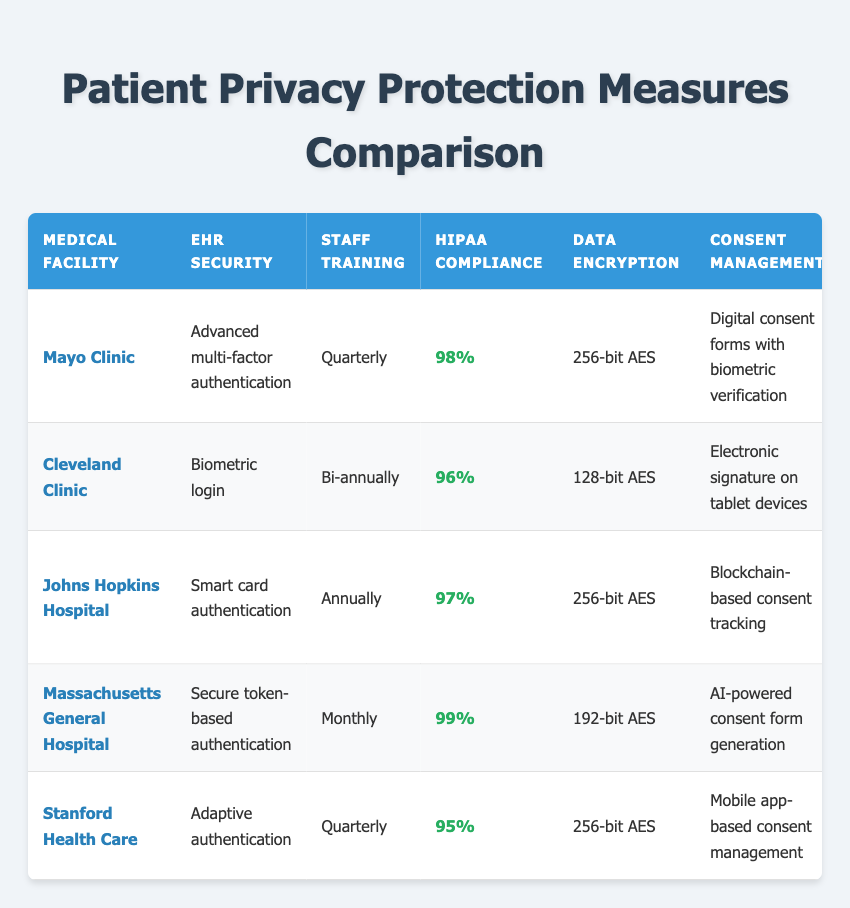What is the highest HIPAA compliance audit score among the facilities? The HIPAA compliance audit scores for the facilities are 98%, 96%, 97%, 99%, and 95%. The highest score is 99%, which belongs to Massachusetts General Hospital.
Answer: 99% How often does Cleveland Clinic conduct staff training? The staff training frequency for Cleveland Clinic is specified in the table as bi-annually.
Answer: Bi-annually Does Johns Hopkins Hospital utilize any form of biometric patient consent management? The table indicates that Johns Hopkins Hospital uses blockchain-based consent tracking for patient consent management, which is a form of digital technology but does not directly mention biometric methods. Therefore, the answer is no.
Answer: No Which facility has the fastest breach notification protocol? The table lists the breach notification protocols: within 24 hours (Mayo Clinic), 48 hours (Cleveland Clinic), 36 hours (Johns Hopkins Hospital), 12 hours (Massachusetts General Hospital), and 72 hours (Stanford Health Care). The fastest is within 12 hours by Massachusetts General Hospital.
Answer: Within 12 hours What is the average HIPAA compliance audit score for all listed facilities? The audit scores are 98%, 96%, 97%, 99%, and 95%. To find the average, sum these scores (98 + 96 + 97 + 99 + 95 = 485) and divide by the number of facilities (485 / 5 = 97). Therefore, the average HIPAA compliance audit score is 97%.
Answer: 97% Which medical facility utilizes two-factor authentication as an access control measure? The table shows that Cleveland Clinic utilizes two-factor authentication for access control measures.
Answer: Cleveland Clinic Is the data encryption level at Mayo Clinic higher than that at Massachusetts General Hospital? The table indicates that Mayo Clinic uses 256-bit AES for data encryption, while Massachusetts General Hospital uses 192-bit AES. Since 256-bit is higher than 192-bit, the answer is yes.
Answer: Yes Which facility has the most frequent staff training sessions? According to the table, Massachusetts General Hospital conducts staff training monthly, which is more frequent than Mayo Clinic (quarterly), Cleveland Clinic (bi-annually), Johns Hopkins Hospital (annually), and Stanford Health Care (quarterly).
Answer: Massachusetts General Hospital What type of access control measures does Stanford Health Care employ? The table specifies that Stanford Health Care employs the least privilege principle for access control measures.
Answer: Least privilege principle 